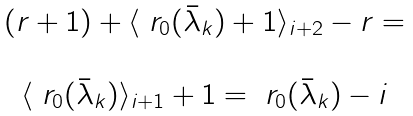<formula> <loc_0><loc_0><loc_500><loc_500>\begin{matrix} \\ ( r + 1 ) + \langle \ r _ { 0 } ( \bar { \lambda } _ { k } ) + 1 \rangle _ { i + 2 } - r = \\ \\ \langle \ r _ { 0 } ( \bar { \lambda } _ { k } ) \rangle _ { i + 1 } + 1 = \ r _ { 0 } ( \bar { \lambda } _ { k } ) - i \\ \ \end{matrix}</formula> 